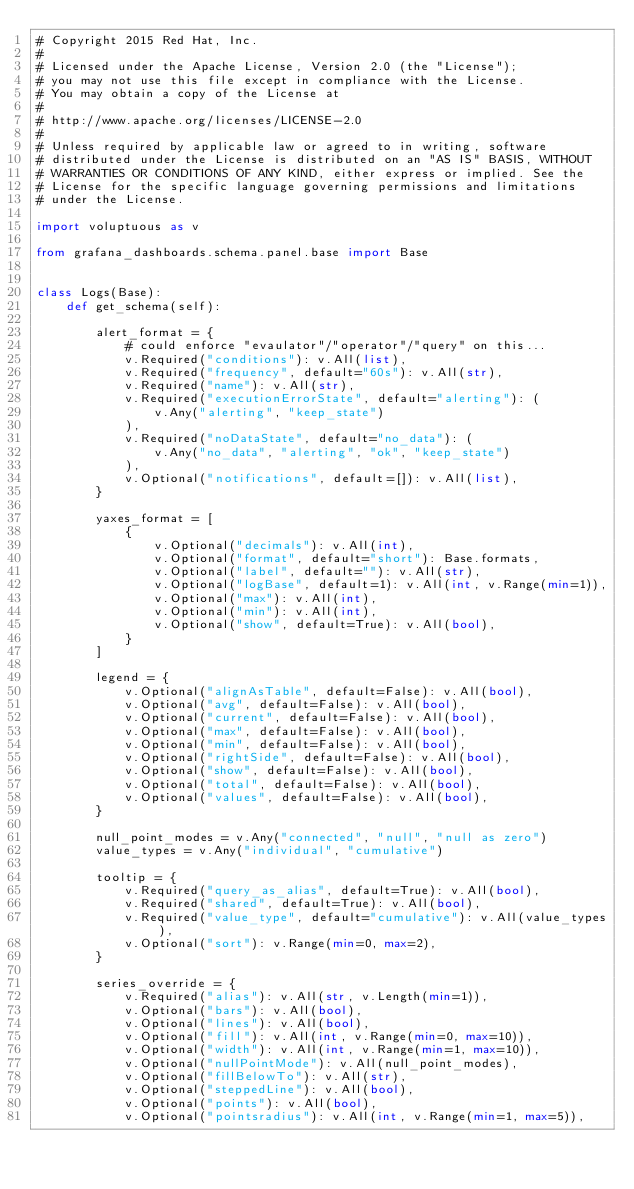<code> <loc_0><loc_0><loc_500><loc_500><_Python_># Copyright 2015 Red Hat, Inc.
#
# Licensed under the Apache License, Version 2.0 (the "License");
# you may not use this file except in compliance with the License.
# You may obtain a copy of the License at
#
# http://www.apache.org/licenses/LICENSE-2.0
#
# Unless required by applicable law or agreed to in writing, software
# distributed under the License is distributed on an "AS IS" BASIS, WITHOUT
# WARRANTIES OR CONDITIONS OF ANY KIND, either express or implied. See the
# License for the specific language governing permissions and limitations
# under the License.

import voluptuous as v

from grafana_dashboards.schema.panel.base import Base


class Logs(Base):
    def get_schema(self):

        alert_format = {
            # could enforce "evaulator"/"operator"/"query" on this...
            v.Required("conditions"): v.All(list),
            v.Required("frequency", default="60s"): v.All(str),
            v.Required("name"): v.All(str),
            v.Required("executionErrorState", default="alerting"): (
                v.Any("alerting", "keep_state")
            ),
            v.Required("noDataState", default="no_data"): (
                v.Any("no_data", "alerting", "ok", "keep_state")
            ),
            v.Optional("notifications", default=[]): v.All(list),
        }

        yaxes_format = [
            {
                v.Optional("decimals"): v.All(int),
                v.Optional("format", default="short"): Base.formats,
                v.Optional("label", default=""): v.All(str),
                v.Optional("logBase", default=1): v.All(int, v.Range(min=1)),
                v.Optional("max"): v.All(int),
                v.Optional("min"): v.All(int),
                v.Optional("show", default=True): v.All(bool),
            }
        ]

        legend = {
            v.Optional("alignAsTable", default=False): v.All(bool),
            v.Optional("avg", default=False): v.All(bool),
            v.Optional("current", default=False): v.All(bool),
            v.Optional("max", default=False): v.All(bool),
            v.Optional("min", default=False): v.All(bool),
            v.Optional("rightSide", default=False): v.All(bool),
            v.Optional("show", default=False): v.All(bool),
            v.Optional("total", default=False): v.All(bool),
            v.Optional("values", default=False): v.All(bool),
        }

        null_point_modes = v.Any("connected", "null", "null as zero")
        value_types = v.Any("individual", "cumulative")

        tooltip = {
            v.Required("query_as_alias", default=True): v.All(bool),
            v.Required("shared", default=True): v.All(bool),
            v.Required("value_type", default="cumulative"): v.All(value_types),
            v.Optional("sort"): v.Range(min=0, max=2),
        }

        series_override = {
            v.Required("alias"): v.All(str, v.Length(min=1)),
            v.Optional("bars"): v.All(bool),
            v.Optional("lines"): v.All(bool),
            v.Optional("fill"): v.All(int, v.Range(min=0, max=10)),
            v.Optional("width"): v.All(int, v.Range(min=1, max=10)),
            v.Optional("nullPointMode"): v.All(null_point_modes),
            v.Optional("fillBelowTo"): v.All(str),
            v.Optional("steppedLine"): v.All(bool),
            v.Optional("points"): v.All(bool),
            v.Optional("pointsradius"): v.All(int, v.Range(min=1, max=5)),</code> 